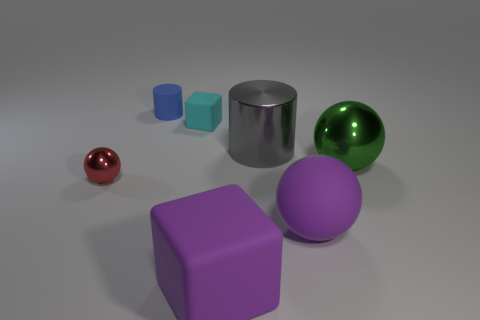Add 3 small green matte things. How many objects exist? 10 Subtract all large spheres. How many spheres are left? 1 Subtract all blocks. How many objects are left? 5 Subtract 2 cylinders. How many cylinders are left? 0 Subtract all purple cubes. How many cubes are left? 1 Subtract all big purple matte cylinders. Subtract all blue matte cylinders. How many objects are left? 6 Add 3 tiny cyan things. How many tiny cyan things are left? 4 Add 1 tiny shiny things. How many tiny shiny things exist? 2 Subtract 0 blue balls. How many objects are left? 7 Subtract all purple cubes. Subtract all purple spheres. How many cubes are left? 1 